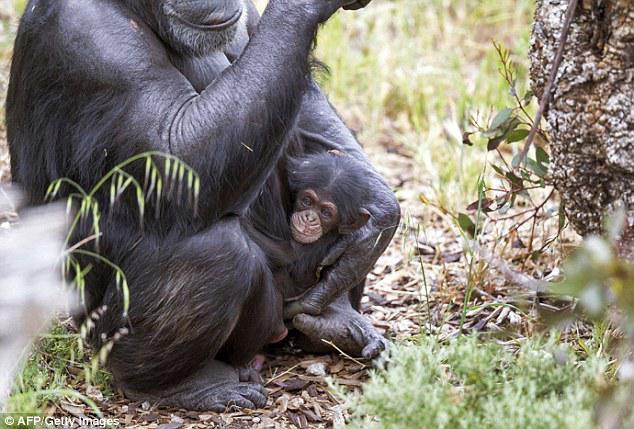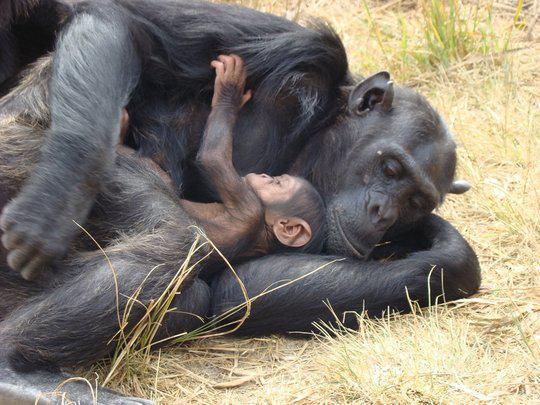The first image is the image on the left, the second image is the image on the right. For the images shown, is this caption "There is two chimpanzees in the right image laying down." true? Answer yes or no. Yes. The first image is the image on the left, the second image is the image on the right. Analyze the images presented: Is the assertion "An image shows a pair of same-sized chimps in a hugging pose." valid? Answer yes or no. No. 